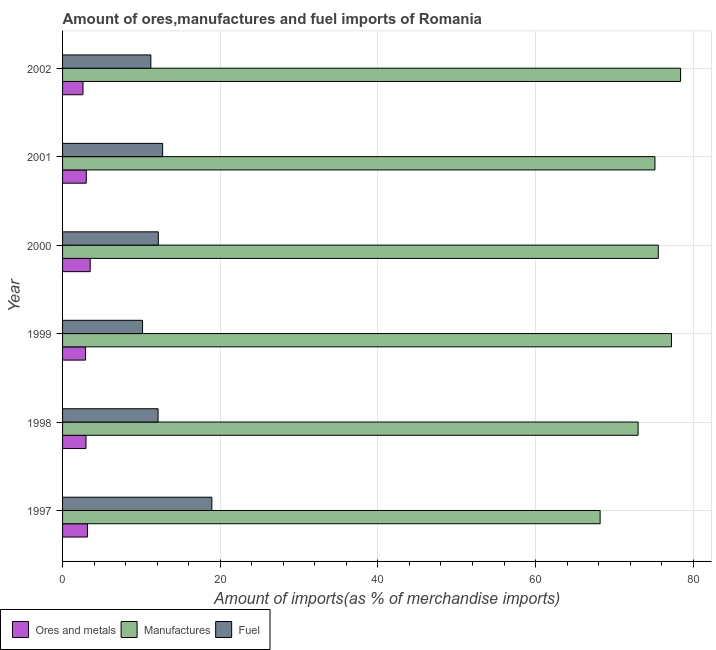How many different coloured bars are there?
Offer a very short reply. 3. How many groups of bars are there?
Your answer should be very brief. 6. Are the number of bars per tick equal to the number of legend labels?
Your response must be concise. Yes. How many bars are there on the 4th tick from the bottom?
Your answer should be very brief. 3. What is the percentage of manufactures imports in 1998?
Give a very brief answer. 73.01. Across all years, what is the maximum percentage of fuel imports?
Your answer should be compact. 18.94. Across all years, what is the minimum percentage of ores and metals imports?
Keep it short and to the point. 2.59. In which year was the percentage of fuel imports minimum?
Your response must be concise. 1999. What is the total percentage of ores and metals imports in the graph?
Provide a succinct answer. 18.15. What is the difference between the percentage of ores and metals imports in 1999 and that in 2001?
Provide a succinct answer. -0.09. What is the difference between the percentage of manufactures imports in 2000 and the percentage of ores and metals imports in 1997?
Your answer should be compact. 72.41. What is the average percentage of ores and metals imports per year?
Make the answer very short. 3.03. In the year 2000, what is the difference between the percentage of manufactures imports and percentage of fuel imports?
Give a very brief answer. 63.42. What is the ratio of the percentage of fuel imports in 1998 to that in 1999?
Offer a very short reply. 1.19. Is the percentage of fuel imports in 1997 less than that in 1999?
Ensure brevity in your answer.  No. Is the difference between the percentage of fuel imports in 1999 and 2000 greater than the difference between the percentage of ores and metals imports in 1999 and 2000?
Make the answer very short. No. What is the difference between the highest and the lowest percentage of fuel imports?
Make the answer very short. 8.79. In how many years, is the percentage of fuel imports greater than the average percentage of fuel imports taken over all years?
Provide a succinct answer. 1. Is the sum of the percentage of fuel imports in 1997 and 1999 greater than the maximum percentage of manufactures imports across all years?
Make the answer very short. No. What does the 1st bar from the top in 2001 represents?
Make the answer very short. Fuel. What does the 2nd bar from the bottom in 1998 represents?
Make the answer very short. Manufactures. How many bars are there?
Make the answer very short. 18. What is the title of the graph?
Your response must be concise. Amount of ores,manufactures and fuel imports of Romania. What is the label or title of the X-axis?
Your answer should be very brief. Amount of imports(as % of merchandise imports). What is the Amount of imports(as % of merchandise imports) in Ores and metals in 1997?
Offer a terse response. 3.16. What is the Amount of imports(as % of merchandise imports) in Manufactures in 1997?
Your response must be concise. 68.19. What is the Amount of imports(as % of merchandise imports) in Fuel in 1997?
Offer a very short reply. 18.94. What is the Amount of imports(as % of merchandise imports) of Ores and metals in 1998?
Ensure brevity in your answer.  2.97. What is the Amount of imports(as % of merchandise imports) of Manufactures in 1998?
Give a very brief answer. 73.01. What is the Amount of imports(as % of merchandise imports) in Fuel in 1998?
Your answer should be compact. 12.12. What is the Amount of imports(as % of merchandise imports) in Ores and metals in 1999?
Your answer should be very brief. 2.92. What is the Amount of imports(as % of merchandise imports) of Manufactures in 1999?
Provide a succinct answer. 77.24. What is the Amount of imports(as % of merchandise imports) of Fuel in 1999?
Your response must be concise. 10.14. What is the Amount of imports(as % of merchandise imports) of Ores and metals in 2000?
Your response must be concise. 3.51. What is the Amount of imports(as % of merchandise imports) in Manufactures in 2000?
Make the answer very short. 75.57. What is the Amount of imports(as % of merchandise imports) in Fuel in 2000?
Give a very brief answer. 12.15. What is the Amount of imports(as % of merchandise imports) in Ores and metals in 2001?
Provide a short and direct response. 3.01. What is the Amount of imports(as % of merchandise imports) of Manufactures in 2001?
Make the answer very short. 75.15. What is the Amount of imports(as % of merchandise imports) of Fuel in 2001?
Ensure brevity in your answer.  12.69. What is the Amount of imports(as % of merchandise imports) of Ores and metals in 2002?
Ensure brevity in your answer.  2.59. What is the Amount of imports(as % of merchandise imports) of Manufactures in 2002?
Make the answer very short. 78.4. What is the Amount of imports(as % of merchandise imports) in Fuel in 2002?
Give a very brief answer. 11.2. Across all years, what is the maximum Amount of imports(as % of merchandise imports) in Ores and metals?
Your response must be concise. 3.51. Across all years, what is the maximum Amount of imports(as % of merchandise imports) of Manufactures?
Offer a terse response. 78.4. Across all years, what is the maximum Amount of imports(as % of merchandise imports) in Fuel?
Provide a succinct answer. 18.94. Across all years, what is the minimum Amount of imports(as % of merchandise imports) of Ores and metals?
Offer a terse response. 2.59. Across all years, what is the minimum Amount of imports(as % of merchandise imports) in Manufactures?
Offer a very short reply. 68.19. Across all years, what is the minimum Amount of imports(as % of merchandise imports) of Fuel?
Ensure brevity in your answer.  10.14. What is the total Amount of imports(as % of merchandise imports) of Ores and metals in the graph?
Provide a short and direct response. 18.15. What is the total Amount of imports(as % of merchandise imports) in Manufactures in the graph?
Provide a short and direct response. 447.54. What is the total Amount of imports(as % of merchandise imports) in Fuel in the graph?
Your answer should be compact. 77.23. What is the difference between the Amount of imports(as % of merchandise imports) of Ores and metals in 1997 and that in 1998?
Your answer should be very brief. 0.18. What is the difference between the Amount of imports(as % of merchandise imports) of Manufactures in 1997 and that in 1998?
Give a very brief answer. -4.82. What is the difference between the Amount of imports(as % of merchandise imports) of Fuel in 1997 and that in 1998?
Your response must be concise. 6.82. What is the difference between the Amount of imports(as % of merchandise imports) of Ores and metals in 1997 and that in 1999?
Offer a terse response. 0.24. What is the difference between the Amount of imports(as % of merchandise imports) of Manufactures in 1997 and that in 1999?
Keep it short and to the point. -9.05. What is the difference between the Amount of imports(as % of merchandise imports) of Fuel in 1997 and that in 1999?
Your response must be concise. 8.79. What is the difference between the Amount of imports(as % of merchandise imports) of Ores and metals in 1997 and that in 2000?
Offer a terse response. -0.35. What is the difference between the Amount of imports(as % of merchandise imports) of Manufactures in 1997 and that in 2000?
Provide a succinct answer. -7.38. What is the difference between the Amount of imports(as % of merchandise imports) in Fuel in 1997 and that in 2000?
Make the answer very short. 6.79. What is the difference between the Amount of imports(as % of merchandise imports) in Ores and metals in 1997 and that in 2001?
Give a very brief answer. 0.15. What is the difference between the Amount of imports(as % of merchandise imports) of Manufactures in 1997 and that in 2001?
Provide a succinct answer. -6.96. What is the difference between the Amount of imports(as % of merchandise imports) in Fuel in 1997 and that in 2001?
Offer a terse response. 6.25. What is the difference between the Amount of imports(as % of merchandise imports) in Ores and metals in 1997 and that in 2002?
Ensure brevity in your answer.  0.57. What is the difference between the Amount of imports(as % of merchandise imports) of Manufactures in 1997 and that in 2002?
Your response must be concise. -10.21. What is the difference between the Amount of imports(as % of merchandise imports) in Fuel in 1997 and that in 2002?
Offer a very short reply. 7.74. What is the difference between the Amount of imports(as % of merchandise imports) of Ores and metals in 1998 and that in 1999?
Keep it short and to the point. 0.05. What is the difference between the Amount of imports(as % of merchandise imports) in Manufactures in 1998 and that in 1999?
Provide a short and direct response. -4.23. What is the difference between the Amount of imports(as % of merchandise imports) in Fuel in 1998 and that in 1999?
Offer a terse response. 1.97. What is the difference between the Amount of imports(as % of merchandise imports) of Ores and metals in 1998 and that in 2000?
Keep it short and to the point. -0.53. What is the difference between the Amount of imports(as % of merchandise imports) of Manufactures in 1998 and that in 2000?
Your response must be concise. -2.56. What is the difference between the Amount of imports(as % of merchandise imports) of Fuel in 1998 and that in 2000?
Ensure brevity in your answer.  -0.03. What is the difference between the Amount of imports(as % of merchandise imports) of Ores and metals in 1998 and that in 2001?
Keep it short and to the point. -0.03. What is the difference between the Amount of imports(as % of merchandise imports) in Manufactures in 1998 and that in 2001?
Provide a short and direct response. -2.14. What is the difference between the Amount of imports(as % of merchandise imports) in Fuel in 1998 and that in 2001?
Provide a succinct answer. -0.58. What is the difference between the Amount of imports(as % of merchandise imports) in Ores and metals in 1998 and that in 2002?
Provide a succinct answer. 0.38. What is the difference between the Amount of imports(as % of merchandise imports) in Manufactures in 1998 and that in 2002?
Provide a succinct answer. -5.39. What is the difference between the Amount of imports(as % of merchandise imports) in Fuel in 1998 and that in 2002?
Offer a very short reply. 0.92. What is the difference between the Amount of imports(as % of merchandise imports) in Ores and metals in 1999 and that in 2000?
Give a very brief answer. -0.59. What is the difference between the Amount of imports(as % of merchandise imports) in Manufactures in 1999 and that in 2000?
Your answer should be compact. 1.67. What is the difference between the Amount of imports(as % of merchandise imports) of Fuel in 1999 and that in 2000?
Offer a very short reply. -2. What is the difference between the Amount of imports(as % of merchandise imports) in Ores and metals in 1999 and that in 2001?
Your answer should be very brief. -0.09. What is the difference between the Amount of imports(as % of merchandise imports) in Manufactures in 1999 and that in 2001?
Ensure brevity in your answer.  2.09. What is the difference between the Amount of imports(as % of merchandise imports) in Fuel in 1999 and that in 2001?
Give a very brief answer. -2.55. What is the difference between the Amount of imports(as % of merchandise imports) in Ores and metals in 1999 and that in 2002?
Make the answer very short. 0.33. What is the difference between the Amount of imports(as % of merchandise imports) in Manufactures in 1999 and that in 2002?
Your answer should be very brief. -1.16. What is the difference between the Amount of imports(as % of merchandise imports) of Fuel in 1999 and that in 2002?
Keep it short and to the point. -1.05. What is the difference between the Amount of imports(as % of merchandise imports) in Ores and metals in 2000 and that in 2001?
Give a very brief answer. 0.5. What is the difference between the Amount of imports(as % of merchandise imports) of Manufactures in 2000 and that in 2001?
Offer a very short reply. 0.42. What is the difference between the Amount of imports(as % of merchandise imports) in Fuel in 2000 and that in 2001?
Offer a terse response. -0.55. What is the difference between the Amount of imports(as % of merchandise imports) in Ores and metals in 2000 and that in 2002?
Give a very brief answer. 0.92. What is the difference between the Amount of imports(as % of merchandise imports) of Manufactures in 2000 and that in 2002?
Make the answer very short. -2.83. What is the difference between the Amount of imports(as % of merchandise imports) in Fuel in 2000 and that in 2002?
Offer a very short reply. 0.95. What is the difference between the Amount of imports(as % of merchandise imports) of Ores and metals in 2001 and that in 2002?
Provide a succinct answer. 0.42. What is the difference between the Amount of imports(as % of merchandise imports) of Manufactures in 2001 and that in 2002?
Offer a very short reply. -3.25. What is the difference between the Amount of imports(as % of merchandise imports) in Fuel in 2001 and that in 2002?
Offer a terse response. 1.49. What is the difference between the Amount of imports(as % of merchandise imports) in Ores and metals in 1997 and the Amount of imports(as % of merchandise imports) in Manufactures in 1998?
Offer a terse response. -69.85. What is the difference between the Amount of imports(as % of merchandise imports) in Ores and metals in 1997 and the Amount of imports(as % of merchandise imports) in Fuel in 1998?
Your answer should be compact. -8.96. What is the difference between the Amount of imports(as % of merchandise imports) of Manufactures in 1997 and the Amount of imports(as % of merchandise imports) of Fuel in 1998?
Give a very brief answer. 56.07. What is the difference between the Amount of imports(as % of merchandise imports) in Ores and metals in 1997 and the Amount of imports(as % of merchandise imports) in Manufactures in 1999?
Provide a succinct answer. -74.08. What is the difference between the Amount of imports(as % of merchandise imports) in Ores and metals in 1997 and the Amount of imports(as % of merchandise imports) in Fuel in 1999?
Offer a terse response. -6.99. What is the difference between the Amount of imports(as % of merchandise imports) of Manufactures in 1997 and the Amount of imports(as % of merchandise imports) of Fuel in 1999?
Ensure brevity in your answer.  58.04. What is the difference between the Amount of imports(as % of merchandise imports) in Ores and metals in 1997 and the Amount of imports(as % of merchandise imports) in Manufactures in 2000?
Make the answer very short. -72.41. What is the difference between the Amount of imports(as % of merchandise imports) in Ores and metals in 1997 and the Amount of imports(as % of merchandise imports) in Fuel in 2000?
Your answer should be very brief. -8.99. What is the difference between the Amount of imports(as % of merchandise imports) in Manufactures in 1997 and the Amount of imports(as % of merchandise imports) in Fuel in 2000?
Offer a terse response. 56.04. What is the difference between the Amount of imports(as % of merchandise imports) of Ores and metals in 1997 and the Amount of imports(as % of merchandise imports) of Manufactures in 2001?
Provide a succinct answer. -71.99. What is the difference between the Amount of imports(as % of merchandise imports) in Ores and metals in 1997 and the Amount of imports(as % of merchandise imports) in Fuel in 2001?
Keep it short and to the point. -9.53. What is the difference between the Amount of imports(as % of merchandise imports) of Manufactures in 1997 and the Amount of imports(as % of merchandise imports) of Fuel in 2001?
Offer a terse response. 55.5. What is the difference between the Amount of imports(as % of merchandise imports) of Ores and metals in 1997 and the Amount of imports(as % of merchandise imports) of Manufactures in 2002?
Ensure brevity in your answer.  -75.24. What is the difference between the Amount of imports(as % of merchandise imports) of Ores and metals in 1997 and the Amount of imports(as % of merchandise imports) of Fuel in 2002?
Provide a short and direct response. -8.04. What is the difference between the Amount of imports(as % of merchandise imports) in Manufactures in 1997 and the Amount of imports(as % of merchandise imports) in Fuel in 2002?
Your response must be concise. 56.99. What is the difference between the Amount of imports(as % of merchandise imports) in Ores and metals in 1998 and the Amount of imports(as % of merchandise imports) in Manufactures in 1999?
Your response must be concise. -74.27. What is the difference between the Amount of imports(as % of merchandise imports) in Ores and metals in 1998 and the Amount of imports(as % of merchandise imports) in Fuel in 1999?
Offer a terse response. -7.17. What is the difference between the Amount of imports(as % of merchandise imports) in Manufactures in 1998 and the Amount of imports(as % of merchandise imports) in Fuel in 1999?
Your response must be concise. 62.86. What is the difference between the Amount of imports(as % of merchandise imports) of Ores and metals in 1998 and the Amount of imports(as % of merchandise imports) of Manufactures in 2000?
Offer a terse response. -72.59. What is the difference between the Amount of imports(as % of merchandise imports) of Ores and metals in 1998 and the Amount of imports(as % of merchandise imports) of Fuel in 2000?
Offer a terse response. -9.17. What is the difference between the Amount of imports(as % of merchandise imports) of Manufactures in 1998 and the Amount of imports(as % of merchandise imports) of Fuel in 2000?
Offer a very short reply. 60.86. What is the difference between the Amount of imports(as % of merchandise imports) in Ores and metals in 1998 and the Amount of imports(as % of merchandise imports) in Manufactures in 2001?
Make the answer very short. -72.17. What is the difference between the Amount of imports(as % of merchandise imports) in Ores and metals in 1998 and the Amount of imports(as % of merchandise imports) in Fuel in 2001?
Provide a short and direct response. -9.72. What is the difference between the Amount of imports(as % of merchandise imports) of Manufactures in 1998 and the Amount of imports(as % of merchandise imports) of Fuel in 2001?
Offer a very short reply. 60.32. What is the difference between the Amount of imports(as % of merchandise imports) of Ores and metals in 1998 and the Amount of imports(as % of merchandise imports) of Manufactures in 2002?
Keep it short and to the point. -75.42. What is the difference between the Amount of imports(as % of merchandise imports) in Ores and metals in 1998 and the Amount of imports(as % of merchandise imports) in Fuel in 2002?
Offer a terse response. -8.23. What is the difference between the Amount of imports(as % of merchandise imports) in Manufactures in 1998 and the Amount of imports(as % of merchandise imports) in Fuel in 2002?
Your answer should be very brief. 61.81. What is the difference between the Amount of imports(as % of merchandise imports) in Ores and metals in 1999 and the Amount of imports(as % of merchandise imports) in Manufactures in 2000?
Your answer should be compact. -72.65. What is the difference between the Amount of imports(as % of merchandise imports) of Ores and metals in 1999 and the Amount of imports(as % of merchandise imports) of Fuel in 2000?
Provide a succinct answer. -9.23. What is the difference between the Amount of imports(as % of merchandise imports) of Manufactures in 1999 and the Amount of imports(as % of merchandise imports) of Fuel in 2000?
Your answer should be very brief. 65.09. What is the difference between the Amount of imports(as % of merchandise imports) in Ores and metals in 1999 and the Amount of imports(as % of merchandise imports) in Manufactures in 2001?
Offer a very short reply. -72.23. What is the difference between the Amount of imports(as % of merchandise imports) in Ores and metals in 1999 and the Amount of imports(as % of merchandise imports) in Fuel in 2001?
Provide a succinct answer. -9.77. What is the difference between the Amount of imports(as % of merchandise imports) of Manufactures in 1999 and the Amount of imports(as % of merchandise imports) of Fuel in 2001?
Your answer should be very brief. 64.55. What is the difference between the Amount of imports(as % of merchandise imports) in Ores and metals in 1999 and the Amount of imports(as % of merchandise imports) in Manufactures in 2002?
Offer a very short reply. -75.48. What is the difference between the Amount of imports(as % of merchandise imports) of Ores and metals in 1999 and the Amount of imports(as % of merchandise imports) of Fuel in 2002?
Provide a succinct answer. -8.28. What is the difference between the Amount of imports(as % of merchandise imports) in Manufactures in 1999 and the Amount of imports(as % of merchandise imports) in Fuel in 2002?
Offer a terse response. 66.04. What is the difference between the Amount of imports(as % of merchandise imports) in Ores and metals in 2000 and the Amount of imports(as % of merchandise imports) in Manufactures in 2001?
Ensure brevity in your answer.  -71.64. What is the difference between the Amount of imports(as % of merchandise imports) of Ores and metals in 2000 and the Amount of imports(as % of merchandise imports) of Fuel in 2001?
Your answer should be compact. -9.19. What is the difference between the Amount of imports(as % of merchandise imports) of Manufactures in 2000 and the Amount of imports(as % of merchandise imports) of Fuel in 2001?
Your answer should be compact. 62.87. What is the difference between the Amount of imports(as % of merchandise imports) in Ores and metals in 2000 and the Amount of imports(as % of merchandise imports) in Manufactures in 2002?
Keep it short and to the point. -74.89. What is the difference between the Amount of imports(as % of merchandise imports) in Ores and metals in 2000 and the Amount of imports(as % of merchandise imports) in Fuel in 2002?
Give a very brief answer. -7.69. What is the difference between the Amount of imports(as % of merchandise imports) in Manufactures in 2000 and the Amount of imports(as % of merchandise imports) in Fuel in 2002?
Offer a terse response. 64.37. What is the difference between the Amount of imports(as % of merchandise imports) of Ores and metals in 2001 and the Amount of imports(as % of merchandise imports) of Manufactures in 2002?
Give a very brief answer. -75.39. What is the difference between the Amount of imports(as % of merchandise imports) of Ores and metals in 2001 and the Amount of imports(as % of merchandise imports) of Fuel in 2002?
Your response must be concise. -8.19. What is the difference between the Amount of imports(as % of merchandise imports) in Manufactures in 2001 and the Amount of imports(as % of merchandise imports) in Fuel in 2002?
Your answer should be very brief. 63.95. What is the average Amount of imports(as % of merchandise imports) of Ores and metals per year?
Offer a very short reply. 3.03. What is the average Amount of imports(as % of merchandise imports) of Manufactures per year?
Give a very brief answer. 74.59. What is the average Amount of imports(as % of merchandise imports) of Fuel per year?
Give a very brief answer. 12.87. In the year 1997, what is the difference between the Amount of imports(as % of merchandise imports) of Ores and metals and Amount of imports(as % of merchandise imports) of Manufactures?
Your answer should be very brief. -65.03. In the year 1997, what is the difference between the Amount of imports(as % of merchandise imports) in Ores and metals and Amount of imports(as % of merchandise imports) in Fuel?
Your answer should be compact. -15.78. In the year 1997, what is the difference between the Amount of imports(as % of merchandise imports) in Manufactures and Amount of imports(as % of merchandise imports) in Fuel?
Give a very brief answer. 49.25. In the year 1998, what is the difference between the Amount of imports(as % of merchandise imports) of Ores and metals and Amount of imports(as % of merchandise imports) of Manufactures?
Your response must be concise. -70.04. In the year 1998, what is the difference between the Amount of imports(as % of merchandise imports) in Ores and metals and Amount of imports(as % of merchandise imports) in Fuel?
Offer a very short reply. -9.14. In the year 1998, what is the difference between the Amount of imports(as % of merchandise imports) in Manufactures and Amount of imports(as % of merchandise imports) in Fuel?
Give a very brief answer. 60.89. In the year 1999, what is the difference between the Amount of imports(as % of merchandise imports) of Ores and metals and Amount of imports(as % of merchandise imports) of Manufactures?
Ensure brevity in your answer.  -74.32. In the year 1999, what is the difference between the Amount of imports(as % of merchandise imports) in Ores and metals and Amount of imports(as % of merchandise imports) in Fuel?
Offer a very short reply. -7.23. In the year 1999, what is the difference between the Amount of imports(as % of merchandise imports) in Manufactures and Amount of imports(as % of merchandise imports) in Fuel?
Provide a short and direct response. 67.09. In the year 2000, what is the difference between the Amount of imports(as % of merchandise imports) of Ores and metals and Amount of imports(as % of merchandise imports) of Manufactures?
Make the answer very short. -72.06. In the year 2000, what is the difference between the Amount of imports(as % of merchandise imports) in Ores and metals and Amount of imports(as % of merchandise imports) in Fuel?
Make the answer very short. -8.64. In the year 2000, what is the difference between the Amount of imports(as % of merchandise imports) of Manufactures and Amount of imports(as % of merchandise imports) of Fuel?
Your answer should be compact. 63.42. In the year 2001, what is the difference between the Amount of imports(as % of merchandise imports) in Ores and metals and Amount of imports(as % of merchandise imports) in Manufactures?
Give a very brief answer. -72.14. In the year 2001, what is the difference between the Amount of imports(as % of merchandise imports) in Ores and metals and Amount of imports(as % of merchandise imports) in Fuel?
Your response must be concise. -9.69. In the year 2001, what is the difference between the Amount of imports(as % of merchandise imports) in Manufactures and Amount of imports(as % of merchandise imports) in Fuel?
Provide a short and direct response. 62.45. In the year 2002, what is the difference between the Amount of imports(as % of merchandise imports) in Ores and metals and Amount of imports(as % of merchandise imports) in Manufactures?
Your response must be concise. -75.81. In the year 2002, what is the difference between the Amount of imports(as % of merchandise imports) in Ores and metals and Amount of imports(as % of merchandise imports) in Fuel?
Provide a succinct answer. -8.61. In the year 2002, what is the difference between the Amount of imports(as % of merchandise imports) in Manufactures and Amount of imports(as % of merchandise imports) in Fuel?
Offer a terse response. 67.2. What is the ratio of the Amount of imports(as % of merchandise imports) of Ores and metals in 1997 to that in 1998?
Ensure brevity in your answer.  1.06. What is the ratio of the Amount of imports(as % of merchandise imports) in Manufactures in 1997 to that in 1998?
Your answer should be compact. 0.93. What is the ratio of the Amount of imports(as % of merchandise imports) in Fuel in 1997 to that in 1998?
Offer a very short reply. 1.56. What is the ratio of the Amount of imports(as % of merchandise imports) in Ores and metals in 1997 to that in 1999?
Give a very brief answer. 1.08. What is the ratio of the Amount of imports(as % of merchandise imports) in Manufactures in 1997 to that in 1999?
Provide a succinct answer. 0.88. What is the ratio of the Amount of imports(as % of merchandise imports) in Fuel in 1997 to that in 1999?
Offer a very short reply. 1.87. What is the ratio of the Amount of imports(as % of merchandise imports) of Ores and metals in 1997 to that in 2000?
Provide a short and direct response. 0.9. What is the ratio of the Amount of imports(as % of merchandise imports) of Manufactures in 1997 to that in 2000?
Keep it short and to the point. 0.9. What is the ratio of the Amount of imports(as % of merchandise imports) of Fuel in 1997 to that in 2000?
Keep it short and to the point. 1.56. What is the ratio of the Amount of imports(as % of merchandise imports) of Ores and metals in 1997 to that in 2001?
Ensure brevity in your answer.  1.05. What is the ratio of the Amount of imports(as % of merchandise imports) of Manufactures in 1997 to that in 2001?
Make the answer very short. 0.91. What is the ratio of the Amount of imports(as % of merchandise imports) in Fuel in 1997 to that in 2001?
Your response must be concise. 1.49. What is the ratio of the Amount of imports(as % of merchandise imports) in Ores and metals in 1997 to that in 2002?
Your response must be concise. 1.22. What is the ratio of the Amount of imports(as % of merchandise imports) of Manufactures in 1997 to that in 2002?
Make the answer very short. 0.87. What is the ratio of the Amount of imports(as % of merchandise imports) in Fuel in 1997 to that in 2002?
Provide a short and direct response. 1.69. What is the ratio of the Amount of imports(as % of merchandise imports) in Ores and metals in 1998 to that in 1999?
Your answer should be very brief. 1.02. What is the ratio of the Amount of imports(as % of merchandise imports) of Manufactures in 1998 to that in 1999?
Your answer should be compact. 0.95. What is the ratio of the Amount of imports(as % of merchandise imports) of Fuel in 1998 to that in 1999?
Make the answer very short. 1.19. What is the ratio of the Amount of imports(as % of merchandise imports) in Ores and metals in 1998 to that in 2000?
Make the answer very short. 0.85. What is the ratio of the Amount of imports(as % of merchandise imports) of Manufactures in 1998 to that in 2000?
Your response must be concise. 0.97. What is the ratio of the Amount of imports(as % of merchandise imports) of Fuel in 1998 to that in 2000?
Provide a short and direct response. 1. What is the ratio of the Amount of imports(as % of merchandise imports) of Ores and metals in 1998 to that in 2001?
Your answer should be compact. 0.99. What is the ratio of the Amount of imports(as % of merchandise imports) in Manufactures in 1998 to that in 2001?
Offer a very short reply. 0.97. What is the ratio of the Amount of imports(as % of merchandise imports) in Fuel in 1998 to that in 2001?
Your response must be concise. 0.95. What is the ratio of the Amount of imports(as % of merchandise imports) of Ores and metals in 1998 to that in 2002?
Provide a succinct answer. 1.15. What is the ratio of the Amount of imports(as % of merchandise imports) of Manufactures in 1998 to that in 2002?
Ensure brevity in your answer.  0.93. What is the ratio of the Amount of imports(as % of merchandise imports) of Fuel in 1998 to that in 2002?
Your answer should be compact. 1.08. What is the ratio of the Amount of imports(as % of merchandise imports) in Ores and metals in 1999 to that in 2000?
Your answer should be very brief. 0.83. What is the ratio of the Amount of imports(as % of merchandise imports) of Manufactures in 1999 to that in 2000?
Keep it short and to the point. 1.02. What is the ratio of the Amount of imports(as % of merchandise imports) in Fuel in 1999 to that in 2000?
Provide a succinct answer. 0.84. What is the ratio of the Amount of imports(as % of merchandise imports) in Ores and metals in 1999 to that in 2001?
Ensure brevity in your answer.  0.97. What is the ratio of the Amount of imports(as % of merchandise imports) of Manufactures in 1999 to that in 2001?
Offer a terse response. 1.03. What is the ratio of the Amount of imports(as % of merchandise imports) of Fuel in 1999 to that in 2001?
Offer a terse response. 0.8. What is the ratio of the Amount of imports(as % of merchandise imports) of Ores and metals in 1999 to that in 2002?
Provide a succinct answer. 1.13. What is the ratio of the Amount of imports(as % of merchandise imports) of Manufactures in 1999 to that in 2002?
Your answer should be compact. 0.99. What is the ratio of the Amount of imports(as % of merchandise imports) of Fuel in 1999 to that in 2002?
Provide a short and direct response. 0.91. What is the ratio of the Amount of imports(as % of merchandise imports) in Ores and metals in 2000 to that in 2001?
Your answer should be very brief. 1.17. What is the ratio of the Amount of imports(as % of merchandise imports) in Manufactures in 2000 to that in 2001?
Offer a very short reply. 1.01. What is the ratio of the Amount of imports(as % of merchandise imports) in Fuel in 2000 to that in 2001?
Offer a terse response. 0.96. What is the ratio of the Amount of imports(as % of merchandise imports) of Ores and metals in 2000 to that in 2002?
Offer a very short reply. 1.35. What is the ratio of the Amount of imports(as % of merchandise imports) of Manufactures in 2000 to that in 2002?
Your answer should be compact. 0.96. What is the ratio of the Amount of imports(as % of merchandise imports) in Fuel in 2000 to that in 2002?
Ensure brevity in your answer.  1.08. What is the ratio of the Amount of imports(as % of merchandise imports) of Ores and metals in 2001 to that in 2002?
Offer a terse response. 1.16. What is the ratio of the Amount of imports(as % of merchandise imports) in Manufactures in 2001 to that in 2002?
Give a very brief answer. 0.96. What is the ratio of the Amount of imports(as % of merchandise imports) of Fuel in 2001 to that in 2002?
Provide a short and direct response. 1.13. What is the difference between the highest and the second highest Amount of imports(as % of merchandise imports) in Ores and metals?
Provide a succinct answer. 0.35. What is the difference between the highest and the second highest Amount of imports(as % of merchandise imports) of Manufactures?
Make the answer very short. 1.16. What is the difference between the highest and the second highest Amount of imports(as % of merchandise imports) in Fuel?
Your response must be concise. 6.25. What is the difference between the highest and the lowest Amount of imports(as % of merchandise imports) in Ores and metals?
Your response must be concise. 0.92. What is the difference between the highest and the lowest Amount of imports(as % of merchandise imports) of Manufactures?
Make the answer very short. 10.21. What is the difference between the highest and the lowest Amount of imports(as % of merchandise imports) in Fuel?
Your answer should be compact. 8.79. 